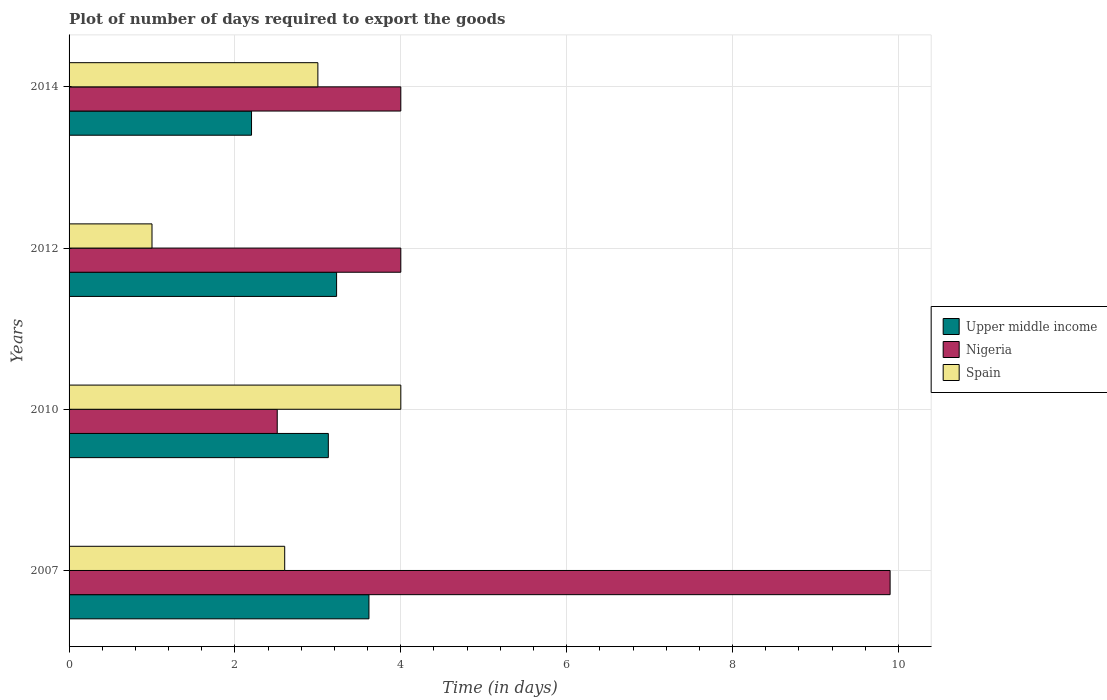How many different coloured bars are there?
Offer a very short reply. 3. How many bars are there on the 4th tick from the top?
Keep it short and to the point. 3. What is the label of the 4th group of bars from the top?
Your answer should be very brief. 2007. In how many cases, is the number of bars for a given year not equal to the number of legend labels?
Provide a short and direct response. 0. What is the time required to export goods in Nigeria in 2010?
Offer a terse response. 2.51. Across all years, what is the minimum time required to export goods in Upper middle income?
Your response must be concise. 2.2. In which year was the time required to export goods in Spain maximum?
Offer a very short reply. 2010. What is the total time required to export goods in Upper middle income in the graph?
Make the answer very short. 12.17. What is the difference between the time required to export goods in Upper middle income in 2007 and that in 2010?
Your response must be concise. 0.49. What is the difference between the time required to export goods in Spain in 2010 and the time required to export goods in Upper middle income in 2014?
Your answer should be compact. 1.8. What is the average time required to export goods in Upper middle income per year?
Offer a terse response. 3.04. In the year 2012, what is the difference between the time required to export goods in Nigeria and time required to export goods in Upper middle income?
Keep it short and to the point. 0.77. In how many years, is the time required to export goods in Upper middle income greater than 7.6 days?
Your response must be concise. 0. What is the ratio of the time required to export goods in Nigeria in 2007 to that in 2010?
Make the answer very short. 3.94. Is the difference between the time required to export goods in Nigeria in 2007 and 2012 greater than the difference between the time required to export goods in Upper middle income in 2007 and 2012?
Ensure brevity in your answer.  Yes. What is the difference between the highest and the second highest time required to export goods in Nigeria?
Provide a succinct answer. 5.9. What is the difference between the highest and the lowest time required to export goods in Upper middle income?
Your answer should be very brief. 1.42. In how many years, is the time required to export goods in Spain greater than the average time required to export goods in Spain taken over all years?
Your answer should be compact. 2. What does the 1st bar from the top in 2012 represents?
Ensure brevity in your answer.  Spain. What does the 1st bar from the bottom in 2012 represents?
Give a very brief answer. Upper middle income. How many years are there in the graph?
Offer a very short reply. 4. What is the difference between two consecutive major ticks on the X-axis?
Your answer should be very brief. 2. Are the values on the major ticks of X-axis written in scientific E-notation?
Offer a very short reply. No. Does the graph contain any zero values?
Ensure brevity in your answer.  No. Does the graph contain grids?
Your answer should be very brief. Yes. Where does the legend appear in the graph?
Offer a very short reply. Center right. How are the legend labels stacked?
Provide a short and direct response. Vertical. What is the title of the graph?
Make the answer very short. Plot of number of days required to export the goods. Does "Mali" appear as one of the legend labels in the graph?
Give a very brief answer. No. What is the label or title of the X-axis?
Offer a terse response. Time (in days). What is the Time (in days) in Upper middle income in 2007?
Your answer should be compact. 3.62. What is the Time (in days) in Nigeria in 2007?
Ensure brevity in your answer.  9.9. What is the Time (in days) in Spain in 2007?
Keep it short and to the point. 2.6. What is the Time (in days) of Upper middle income in 2010?
Keep it short and to the point. 3.13. What is the Time (in days) in Nigeria in 2010?
Ensure brevity in your answer.  2.51. What is the Time (in days) of Upper middle income in 2012?
Offer a terse response. 3.23. What is the Time (in days) of Nigeria in 2012?
Provide a short and direct response. 4. What is the Time (in days) of Nigeria in 2014?
Make the answer very short. 4. Across all years, what is the maximum Time (in days) of Upper middle income?
Your response must be concise. 3.62. Across all years, what is the minimum Time (in days) in Nigeria?
Offer a terse response. 2.51. What is the total Time (in days) in Upper middle income in the graph?
Give a very brief answer. 12.17. What is the total Time (in days) of Nigeria in the graph?
Ensure brevity in your answer.  20.41. What is the total Time (in days) in Spain in the graph?
Your answer should be very brief. 10.6. What is the difference between the Time (in days) in Upper middle income in 2007 and that in 2010?
Provide a short and direct response. 0.49. What is the difference between the Time (in days) of Nigeria in 2007 and that in 2010?
Provide a succinct answer. 7.39. What is the difference between the Time (in days) of Upper middle income in 2007 and that in 2012?
Ensure brevity in your answer.  0.39. What is the difference between the Time (in days) of Nigeria in 2007 and that in 2012?
Your answer should be very brief. 5.9. What is the difference between the Time (in days) in Spain in 2007 and that in 2012?
Make the answer very short. 1.6. What is the difference between the Time (in days) of Upper middle income in 2007 and that in 2014?
Offer a terse response. 1.42. What is the difference between the Time (in days) in Nigeria in 2007 and that in 2014?
Your answer should be very brief. 5.9. What is the difference between the Time (in days) of Upper middle income in 2010 and that in 2012?
Ensure brevity in your answer.  -0.1. What is the difference between the Time (in days) of Nigeria in 2010 and that in 2012?
Ensure brevity in your answer.  -1.49. What is the difference between the Time (in days) of Upper middle income in 2010 and that in 2014?
Keep it short and to the point. 0.93. What is the difference between the Time (in days) of Nigeria in 2010 and that in 2014?
Provide a short and direct response. -1.49. What is the difference between the Time (in days) of Upper middle income in 2012 and that in 2014?
Offer a very short reply. 1.03. What is the difference between the Time (in days) in Nigeria in 2012 and that in 2014?
Offer a very short reply. 0. What is the difference between the Time (in days) in Spain in 2012 and that in 2014?
Your answer should be compact. -2. What is the difference between the Time (in days) in Upper middle income in 2007 and the Time (in days) in Nigeria in 2010?
Ensure brevity in your answer.  1.11. What is the difference between the Time (in days) of Upper middle income in 2007 and the Time (in days) of Spain in 2010?
Keep it short and to the point. -0.38. What is the difference between the Time (in days) in Nigeria in 2007 and the Time (in days) in Spain in 2010?
Make the answer very short. 5.9. What is the difference between the Time (in days) of Upper middle income in 2007 and the Time (in days) of Nigeria in 2012?
Keep it short and to the point. -0.38. What is the difference between the Time (in days) of Upper middle income in 2007 and the Time (in days) of Spain in 2012?
Provide a short and direct response. 2.62. What is the difference between the Time (in days) of Upper middle income in 2007 and the Time (in days) of Nigeria in 2014?
Offer a terse response. -0.38. What is the difference between the Time (in days) of Upper middle income in 2007 and the Time (in days) of Spain in 2014?
Your response must be concise. 0.62. What is the difference between the Time (in days) of Upper middle income in 2010 and the Time (in days) of Nigeria in 2012?
Your answer should be compact. -0.87. What is the difference between the Time (in days) in Upper middle income in 2010 and the Time (in days) in Spain in 2012?
Offer a terse response. 2.13. What is the difference between the Time (in days) of Nigeria in 2010 and the Time (in days) of Spain in 2012?
Give a very brief answer. 1.51. What is the difference between the Time (in days) of Upper middle income in 2010 and the Time (in days) of Nigeria in 2014?
Ensure brevity in your answer.  -0.87. What is the difference between the Time (in days) of Upper middle income in 2010 and the Time (in days) of Spain in 2014?
Your response must be concise. 0.13. What is the difference between the Time (in days) in Nigeria in 2010 and the Time (in days) in Spain in 2014?
Give a very brief answer. -0.49. What is the difference between the Time (in days) of Upper middle income in 2012 and the Time (in days) of Nigeria in 2014?
Offer a very short reply. -0.77. What is the difference between the Time (in days) in Upper middle income in 2012 and the Time (in days) in Spain in 2014?
Ensure brevity in your answer.  0.23. What is the difference between the Time (in days) in Nigeria in 2012 and the Time (in days) in Spain in 2014?
Give a very brief answer. 1. What is the average Time (in days) of Upper middle income per year?
Your answer should be compact. 3.04. What is the average Time (in days) in Nigeria per year?
Offer a very short reply. 5.1. What is the average Time (in days) in Spain per year?
Provide a short and direct response. 2.65. In the year 2007, what is the difference between the Time (in days) of Upper middle income and Time (in days) of Nigeria?
Keep it short and to the point. -6.28. In the year 2010, what is the difference between the Time (in days) of Upper middle income and Time (in days) of Nigeria?
Make the answer very short. 0.62. In the year 2010, what is the difference between the Time (in days) of Upper middle income and Time (in days) of Spain?
Your response must be concise. -0.87. In the year 2010, what is the difference between the Time (in days) of Nigeria and Time (in days) of Spain?
Offer a terse response. -1.49. In the year 2012, what is the difference between the Time (in days) of Upper middle income and Time (in days) of Nigeria?
Offer a terse response. -0.77. In the year 2012, what is the difference between the Time (in days) in Upper middle income and Time (in days) in Spain?
Your answer should be compact. 2.23. In the year 2012, what is the difference between the Time (in days) in Nigeria and Time (in days) in Spain?
Keep it short and to the point. 3. In the year 2014, what is the difference between the Time (in days) of Nigeria and Time (in days) of Spain?
Ensure brevity in your answer.  1. What is the ratio of the Time (in days) in Upper middle income in 2007 to that in 2010?
Keep it short and to the point. 1.16. What is the ratio of the Time (in days) of Nigeria in 2007 to that in 2010?
Offer a very short reply. 3.94. What is the ratio of the Time (in days) in Spain in 2007 to that in 2010?
Ensure brevity in your answer.  0.65. What is the ratio of the Time (in days) in Upper middle income in 2007 to that in 2012?
Ensure brevity in your answer.  1.12. What is the ratio of the Time (in days) in Nigeria in 2007 to that in 2012?
Provide a short and direct response. 2.48. What is the ratio of the Time (in days) of Upper middle income in 2007 to that in 2014?
Make the answer very short. 1.64. What is the ratio of the Time (in days) in Nigeria in 2007 to that in 2014?
Your answer should be very brief. 2.48. What is the ratio of the Time (in days) of Spain in 2007 to that in 2014?
Your response must be concise. 0.87. What is the ratio of the Time (in days) in Upper middle income in 2010 to that in 2012?
Your response must be concise. 0.97. What is the ratio of the Time (in days) of Nigeria in 2010 to that in 2012?
Ensure brevity in your answer.  0.63. What is the ratio of the Time (in days) in Upper middle income in 2010 to that in 2014?
Give a very brief answer. 1.42. What is the ratio of the Time (in days) of Nigeria in 2010 to that in 2014?
Your answer should be very brief. 0.63. What is the ratio of the Time (in days) of Upper middle income in 2012 to that in 2014?
Keep it short and to the point. 1.47. What is the ratio of the Time (in days) of Nigeria in 2012 to that in 2014?
Offer a very short reply. 1. What is the difference between the highest and the second highest Time (in days) of Upper middle income?
Offer a terse response. 0.39. What is the difference between the highest and the second highest Time (in days) of Spain?
Your answer should be compact. 1. What is the difference between the highest and the lowest Time (in days) of Upper middle income?
Offer a very short reply. 1.42. What is the difference between the highest and the lowest Time (in days) in Nigeria?
Provide a short and direct response. 7.39. What is the difference between the highest and the lowest Time (in days) in Spain?
Offer a terse response. 3. 